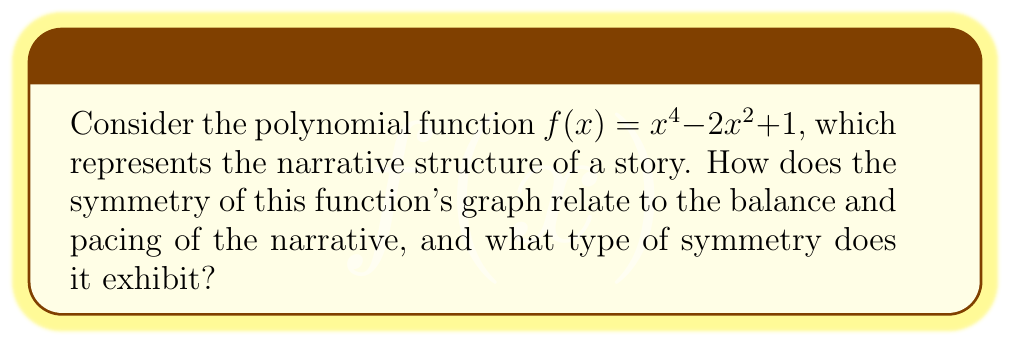Could you help me with this problem? Let's analyze the symmetry of the given polynomial function step-by-step:

1. First, we need to determine if the function is even or odd:
   $f(-x) = (-x)^4 - 2(-x)^2 + 1$
   $= x^4 - 2x^2 + 1$
   $= f(x)$

   Since $f(-x) = f(x)$, the function is even.

2. Even functions are symmetric about the y-axis. This means that for every point $(a, b)$ on the graph, there is a corresponding point $(-a, b)$.

3. The graph of $f(x) = x^4 - 2x^2 + 1$ is a quartic function with a W-shape:

   [asy]
   import graph;
   size(200);
   real f(real x) {return x^4 - 2x^2 + 1;}
   draw(graph(f, -2, 2), blue);
   xaxis("x");
   yaxis("y");
   [/asy]

4. In terms of narrative structure, this symmetry can be interpreted as follows:
   - The y-axis represents the midpoint of the story.
   - The left side of the graph corresponds to the first half of the narrative, while the right side represents the second half.
   - The symmetry implies that events or plot points in the first half have corresponding counterparts in the second half, creating a balanced structure.
   - The W-shape suggests a story with two major conflicts or turning points (the two low points of the W) and three high points (the two outer peaks and the center).

5. This type of symmetry in narrative structure is often seen in chiastic or ring composition, where themes, events, or character arcs are mirrored around a central point, creating a sense of balance and closure in the story.
Answer: Even symmetry about the y-axis, reflecting a balanced narrative structure with mirrored elements around the story's midpoint. 